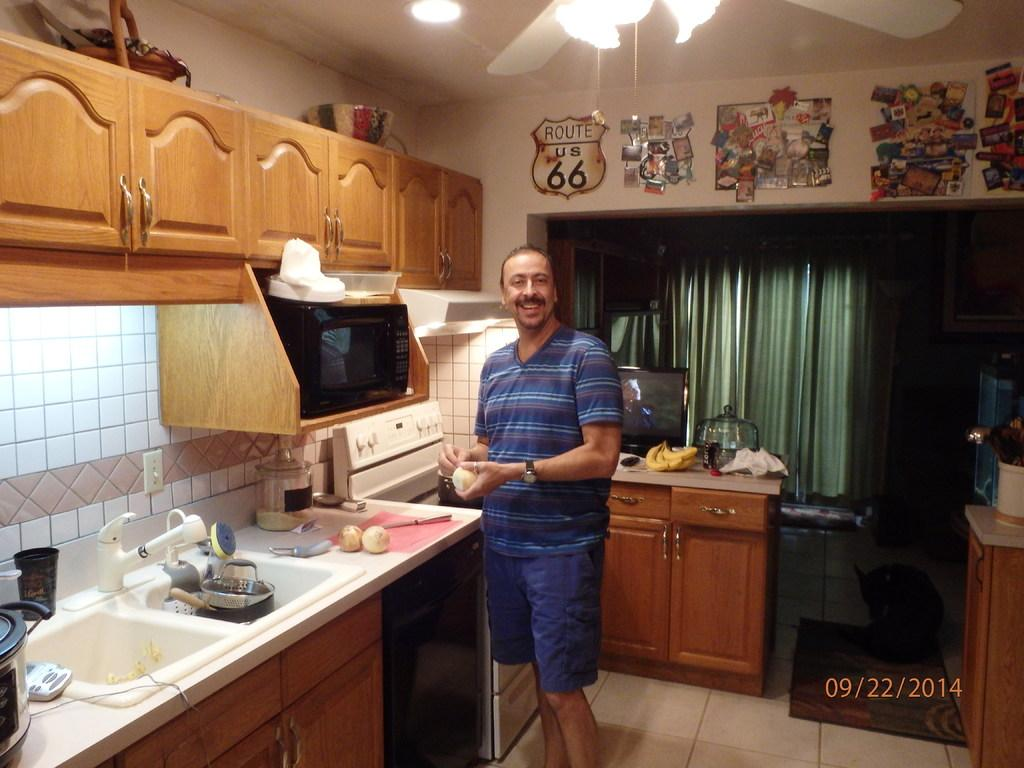Provide a one-sentence caption for the provided image. A man cooking in his kitchen on September 22, 2014. 